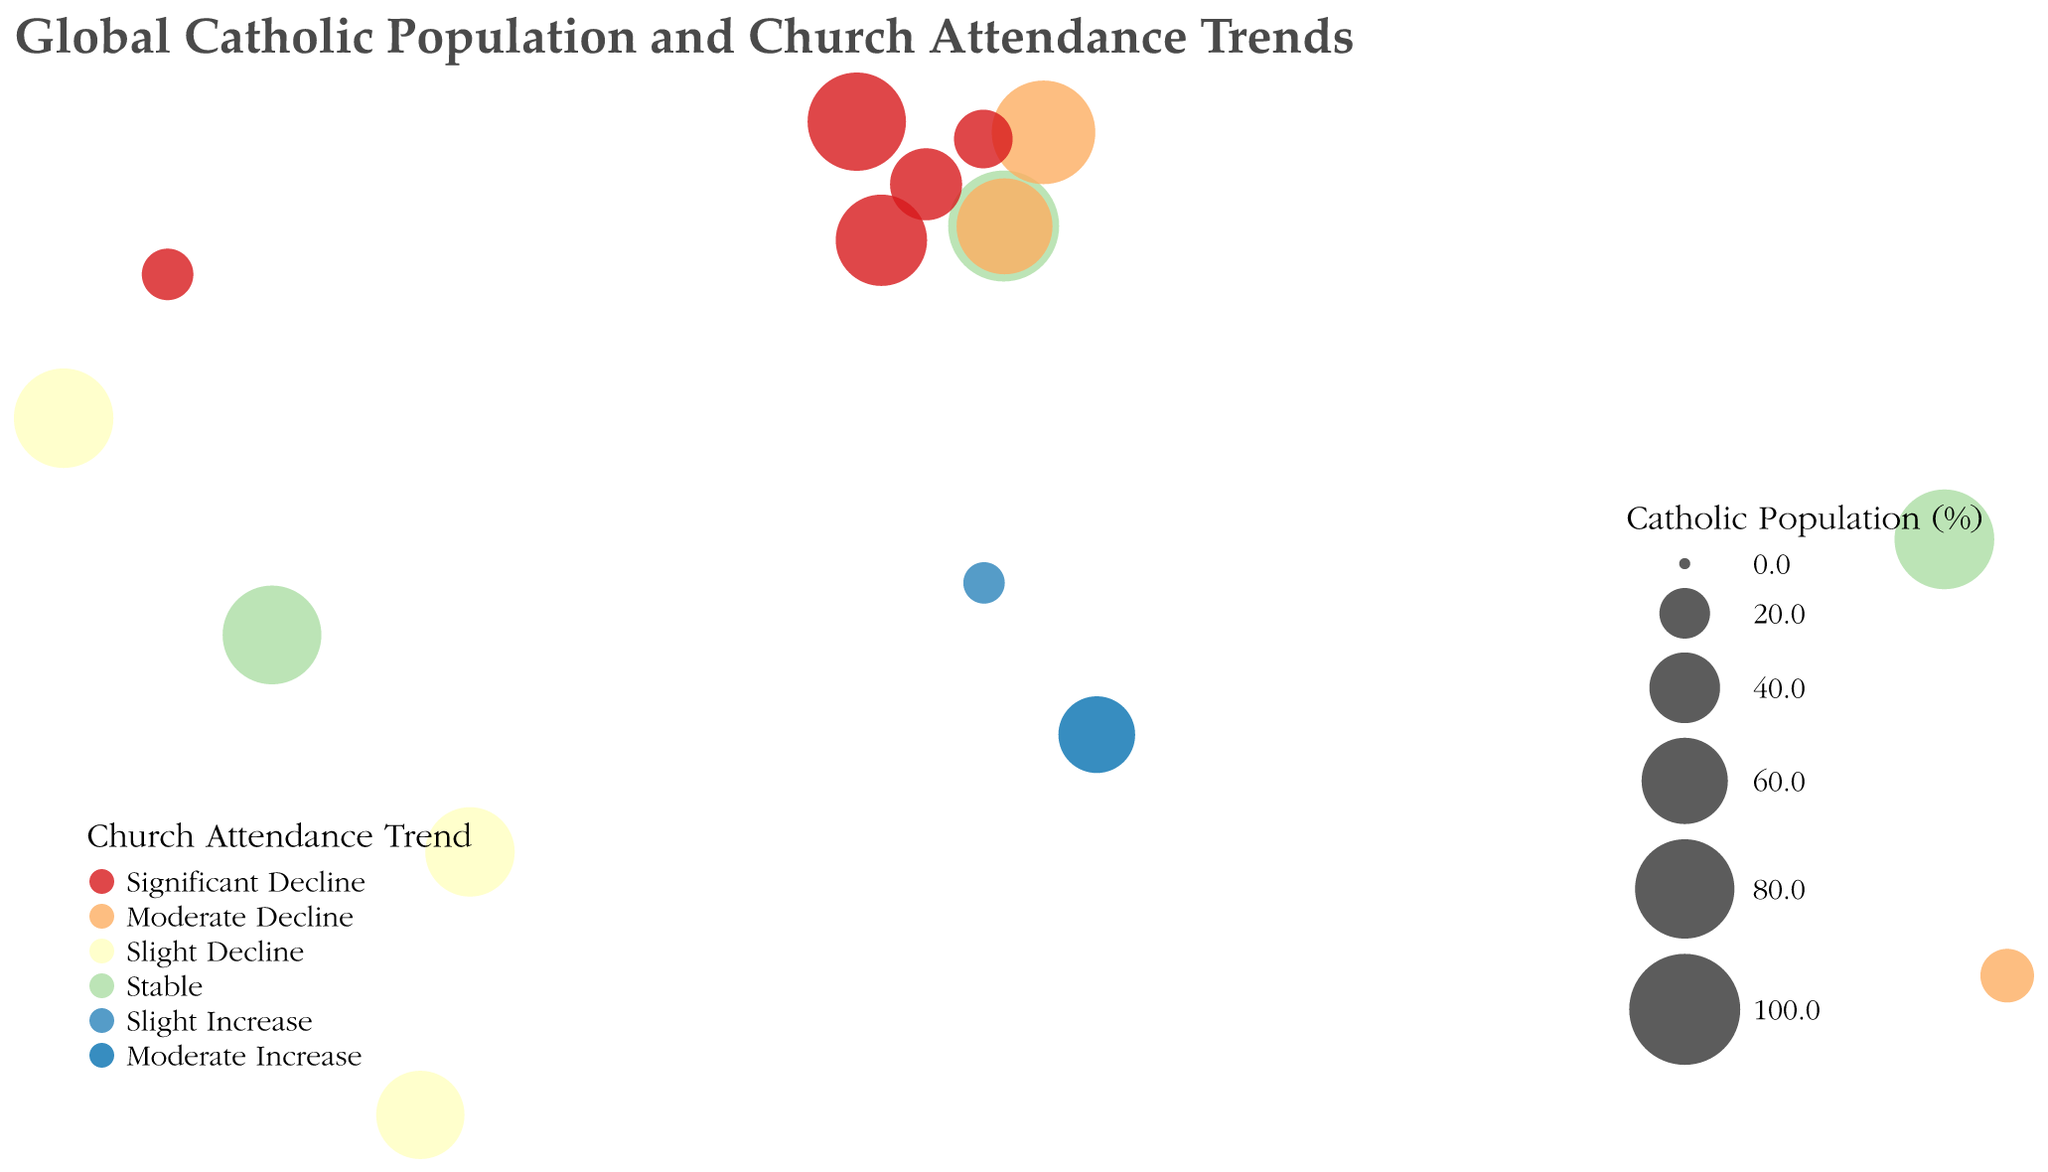What's the title of the figure? The title is displayed at the top of the figure in large font and states the main topic.
Answer: Global Catholic Population and Church Attendance Trends How many countries show a significant decline in church attendance? Look for the categories marked with the color that represents "Significant Decline" and count the number of countries.
Answer: 5 Which country has the highest percentage of the Catholic population? Identify the largest circle on the map, which represents the highest Catholic population percentage.
Answer: Vatican City What is the church attendance trend in the Philippines? Look at the color of the circle representing the Philippines and match it to the legend.
Answer: Stable Which continents have countries with a moderate increase in church attendance? Identify the countries with a moderate increase from the color legend and locate their positions on the map.
Answer: Africa Compare the Catholic population percentages of the United States and Brazil. Which one is higher and by how much? Locate the circles representing the United States and Brazil, check their sizes or percentages from the figure's tooltip, then compute the difference.
Answer: Brazil is higher by 43.8% What is the common church attendance trend among European countries listed on the map? Identify European countries and evaluate the common trend in their church attendance colors.
Answer: Significant Decline Which country in South America has the highest Catholic population percentage? Identify the South American countries and compare their circle sizes or percentages.
Answer: Colombia How does the Catholic population percentage in Nigeria compare to that in France? Check the circle sizes or tooltip percentages of Nigeria and France, then compare the values.
Answer: France is higher by 28.5% What general trend can be observed in church attendance in countries with a high (>70%) Catholic population percentage? Observe the colors associated with countries having large circles, which represent higher Catholic population percentages, and generalize the attendance trend.
Answer: Mostly stable or declining 